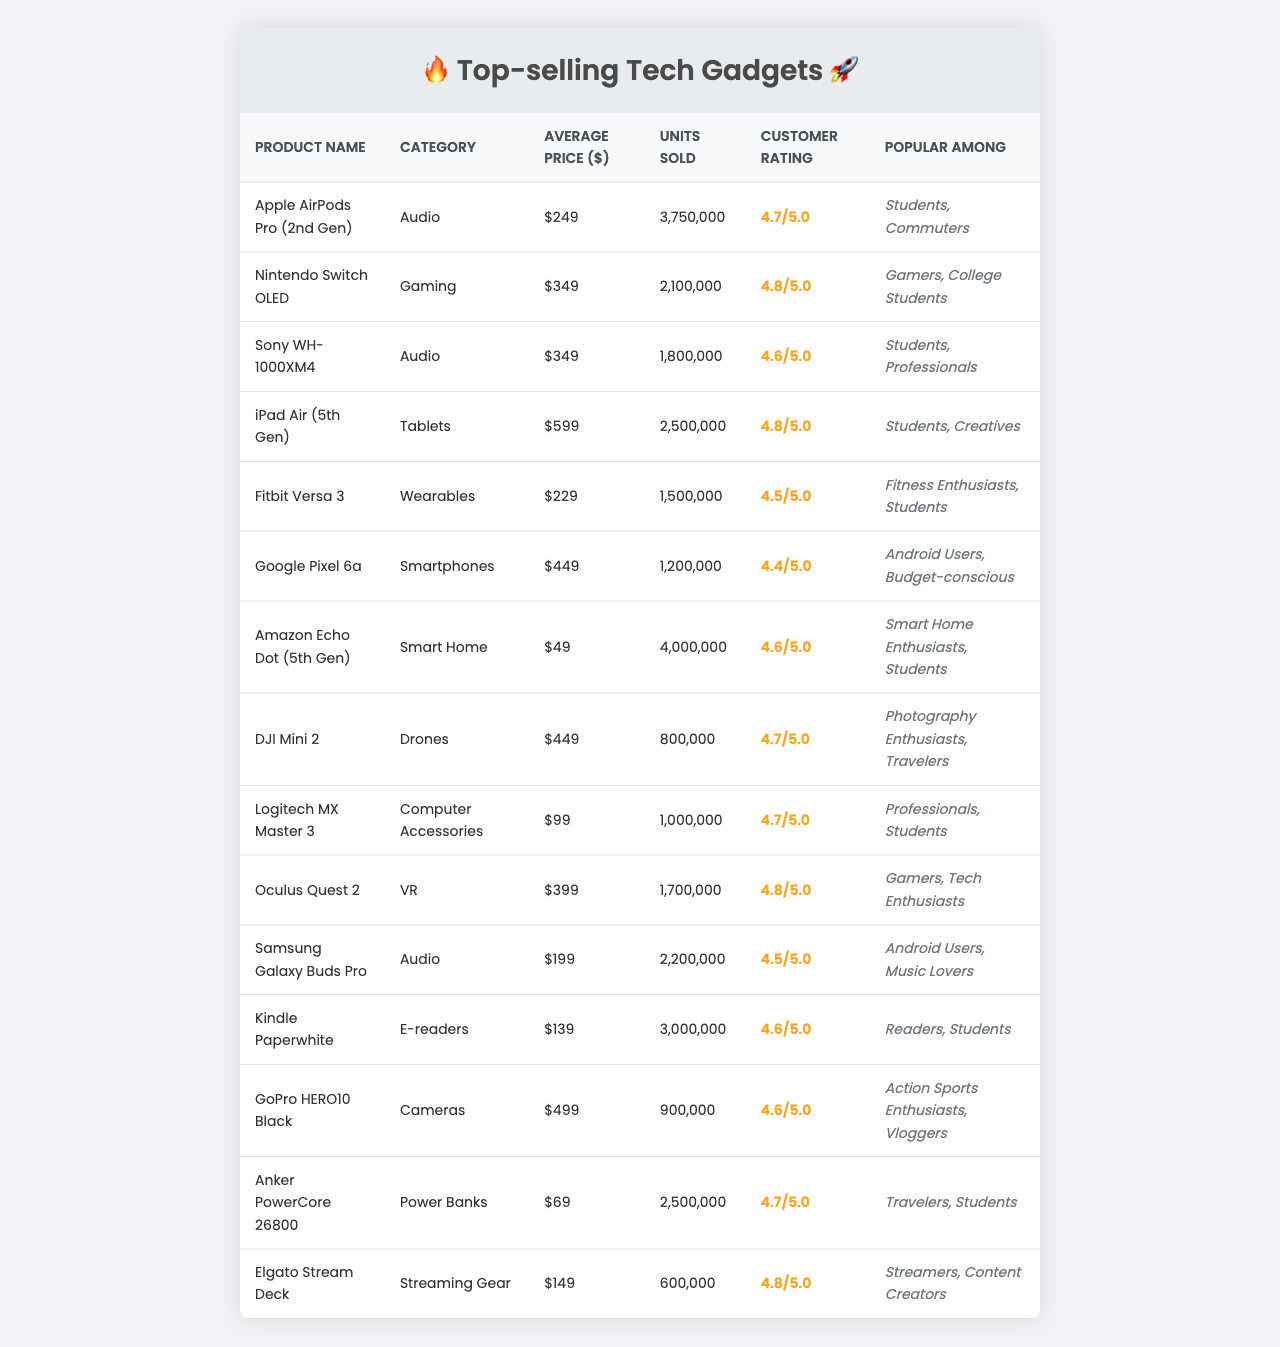What is the average price of the top-selling gadgets? To find the average price, sum all the average prices of the gadgets: 249 + 349 + 349 + 599 + 229 + 449 + 49 + 449 + 99 + 399 + 199 + 139 + 499 + 69 + 149 = 3,923. Then, divide by the number of gadgets (15), resulting in 3,923 / 15 = 261.53.
Answer: 261.53 Which product has the highest customer rating? By reviewing the customer ratings, the highest rating is 4.8. The products with this rating are the Nintendo Switch OLED, iPad Air (5th Gen), and Oculus Quest 2.
Answer: Nintendo Switch OLED, iPad Air (5th Gen), Oculus Quest 2 How many units were sold for the Amazon Echo Dot (5th Gen)? The table shows that the Amazon Echo Dot (5th Gen) sold 4,000,000 units.
Answer: 4,000,000 What is the total number of units sold for audio products? The audio products are Apple AirPods Pro (2nd Gen), Sony WH-1000XM4, and Samsung Galaxy Buds Pro. Their units sold are 3,750,000 + 1,800,000 + 2,200,000 = 7,750,000.
Answer: 7,750,000 Is the Kindle Paperwhite more popular among students or readers? The Kindle Paperwhite is popular among both readers and students. However, since "Readers" is listed as its first target audience, it is primarily aimed at them.
Answer: Yes How much more expensive is the iPad Air (5th Gen) compared to the Google Pixel 6a? The average price of the iPad Air (5th Gen) is 599, and for Google Pixel 6a it is 449. The difference is 599 - 449 = 150.
Answer: 150 What percentage of total units sold does the DJI Mini 2 account for? The total units sold across all products is 18,200,000. The DJI Mini 2 sold 800,000 units. Calculate the percentage as: (800,000 / 18,200,000) * 100 ≈ 4.41%.
Answer: 4.41% Which product categories are popular among students? The table lists Apple AirPods Pro (2nd Gen), Sony WH-1000XM4, iPad Air (5th Gen), Fitbit Versa 3, Amazon Echo Dot (5th Gen), Logitech MX Master 3, and Anker PowerCore 26800 as popular among students.
Answer: Audio, Tablets, Wearables, Smart Home, Computer Accessories, Power Banks What is the average customer rating of gaming gadgets? The gaming gadgets are Nintendo Switch OLED and Oculus Quest 2, with ratings of 4.8 and 4.8 respectively. The average rating is (4.8 + 4.8) / 2 = 4.8.
Answer: 4.8 How many units did the GoPro HERO10 Black sell compared to the Fitbit Versa 3? GoPro HERO10 Black sold 900,000 units and Fitbit Versa 3 sold 1,500,000 units. The difference is 1,500,000 - 900,000 = 600,000, so Fitbit Versa 3 sold 600,000 more.
Answer: 600,000 